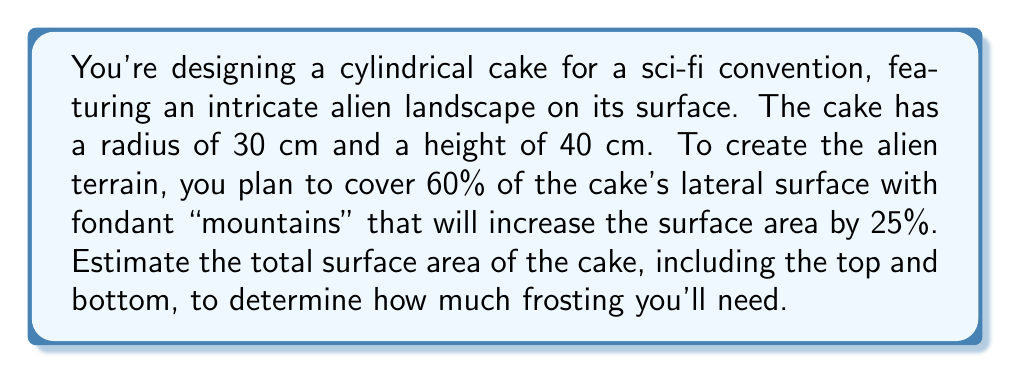Show me your answer to this math problem. Let's approach this step-by-step:

1) First, calculate the surface area of a plain cylindrical cake:
   - Lateral surface area: $A_l = 2\pi rh$
   - Top and bottom area: $A_{tb} = 2\pi r^2$
   - Total surface area: $A_t = A_l + A_{tb}$

   $$A_l = 2\pi (30 \text{ cm})(40 \text{ cm}) = 7539.82 \text{ cm}^2$$
   $$A_{tb} = 2\pi (30 \text{ cm})^2 = 5654.87 \text{ cm}^2$$
   $$A_t = 7539.82 \text{ cm}^2 + 5654.87 \text{ cm}^2 = 13194.69 \text{ cm}^2$$

2) Calculate the area of the lateral surface that will be covered with "mountains":
   $$A_{\text{mountain base}} = 60\% \times 7539.82 \text{ cm}^2 = 4523.89 \text{ cm}^2$$

3) Calculate the increased surface area due to the "mountains":
   $$A_{\text{mountain increase}} = 25\% \times 4523.89 \text{ cm}^2 = 1130.97 \text{ cm}^2$$

4) Calculate the total surface area including the "mountains":
   $$A_{\text{total}} = A_t + A_{\text{mountain increase}}$$
   $$A_{\text{total}} = 13194.69 \text{ cm}^2 + 1130.97 \text{ cm}^2 = 14325.66 \text{ cm}^2$$

5) Round to a reasonable number of significant figures for estimation:
   $$A_{\text{total}} \approx 14300 \text{ cm}^2$$
Answer: $14300 \text{ cm}^2$ 